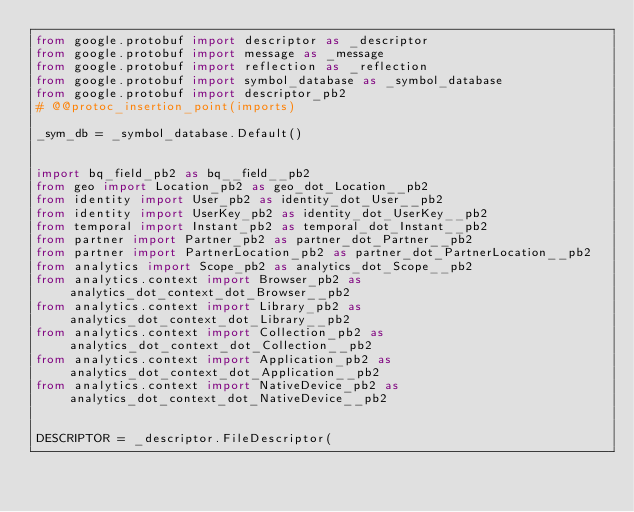<code> <loc_0><loc_0><loc_500><loc_500><_Python_>from google.protobuf import descriptor as _descriptor
from google.protobuf import message as _message
from google.protobuf import reflection as _reflection
from google.protobuf import symbol_database as _symbol_database
from google.protobuf import descriptor_pb2
# @@protoc_insertion_point(imports)

_sym_db = _symbol_database.Default()


import bq_field_pb2 as bq__field__pb2
from geo import Location_pb2 as geo_dot_Location__pb2
from identity import User_pb2 as identity_dot_User__pb2
from identity import UserKey_pb2 as identity_dot_UserKey__pb2
from temporal import Instant_pb2 as temporal_dot_Instant__pb2
from partner import Partner_pb2 as partner_dot_Partner__pb2
from partner import PartnerLocation_pb2 as partner_dot_PartnerLocation__pb2
from analytics import Scope_pb2 as analytics_dot_Scope__pb2
from analytics.context import Browser_pb2 as analytics_dot_context_dot_Browser__pb2
from analytics.context import Library_pb2 as analytics_dot_context_dot_Library__pb2
from analytics.context import Collection_pb2 as analytics_dot_context_dot_Collection__pb2
from analytics.context import Application_pb2 as analytics_dot_context_dot_Application__pb2
from analytics.context import NativeDevice_pb2 as analytics_dot_context_dot_NativeDevice__pb2


DESCRIPTOR = _descriptor.FileDescriptor(</code> 